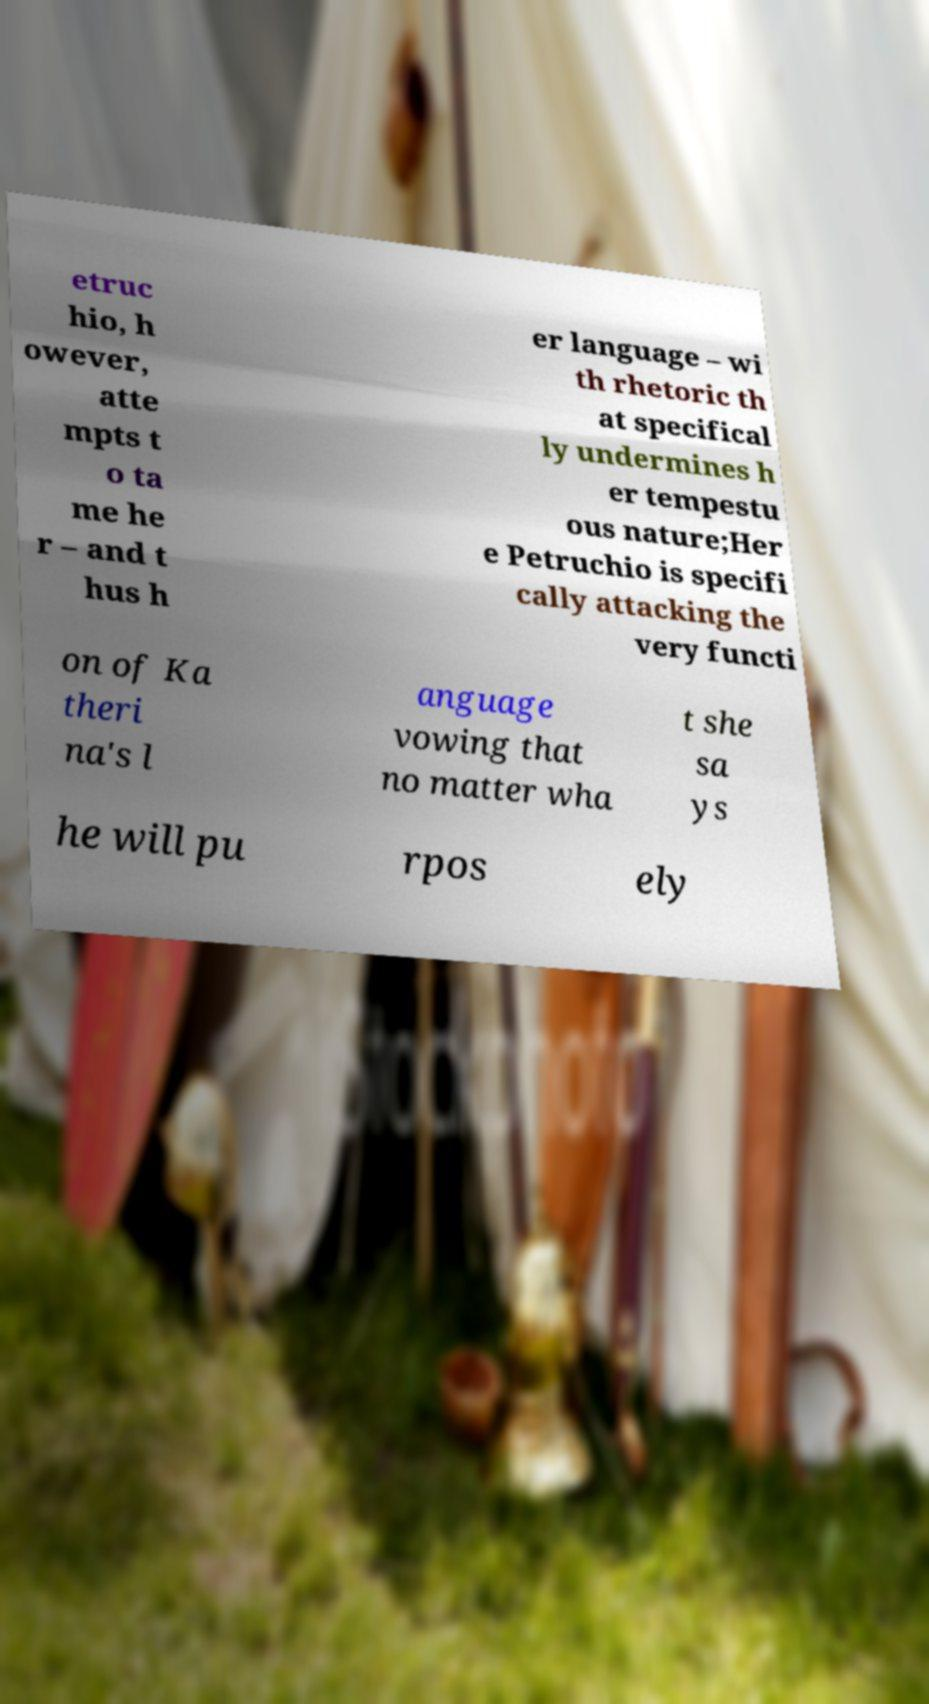For documentation purposes, I need the text within this image transcribed. Could you provide that? etruc hio, h owever, atte mpts t o ta me he r – and t hus h er language – wi th rhetoric th at specifical ly undermines h er tempestu ous nature;Her e Petruchio is specifi cally attacking the very functi on of Ka theri na's l anguage vowing that no matter wha t she sa ys he will pu rpos ely 